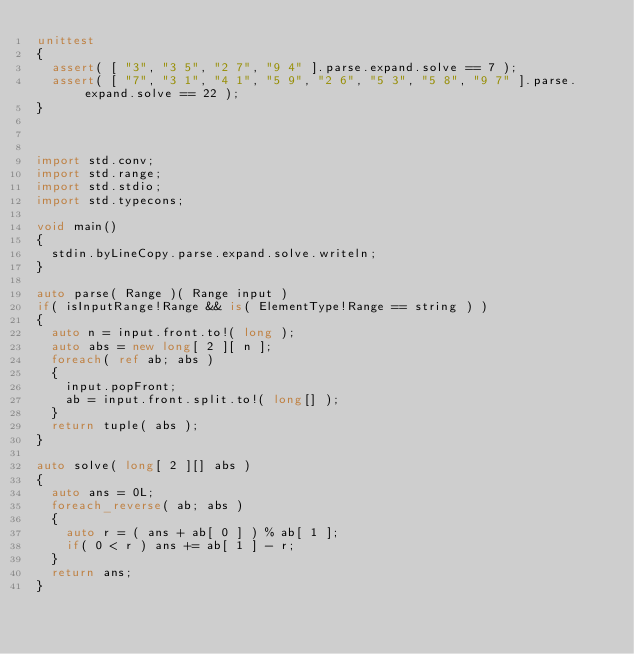<code> <loc_0><loc_0><loc_500><loc_500><_D_>unittest
{
	assert( [ "3", "3 5", "2 7", "9 4" ].parse.expand.solve == 7 );
	assert( [ "7", "3 1", "4 1", "5 9", "2 6", "5 3", "5 8", "9 7" ].parse.expand.solve == 22 );
}



import std.conv;
import std.range;
import std.stdio;
import std.typecons;

void main()
{
	stdin.byLineCopy.parse.expand.solve.writeln;
}

auto parse( Range )( Range input )
if( isInputRange!Range && is( ElementType!Range == string ) )
{
	auto n = input.front.to!( long );
	auto abs = new long[ 2 ][ n ];
	foreach( ref ab; abs )
	{
		input.popFront;
		ab = input.front.split.to!( long[] );
	}
	return tuple( abs );
}

auto solve( long[ 2 ][] abs )
{
	auto ans = 0L;
	foreach_reverse( ab; abs )
	{
		auto r = ( ans + ab[ 0 ] ) % ab[ 1 ];
		if( 0 < r ) ans += ab[ 1 ] - r;
	}
	return ans;
}
</code> 